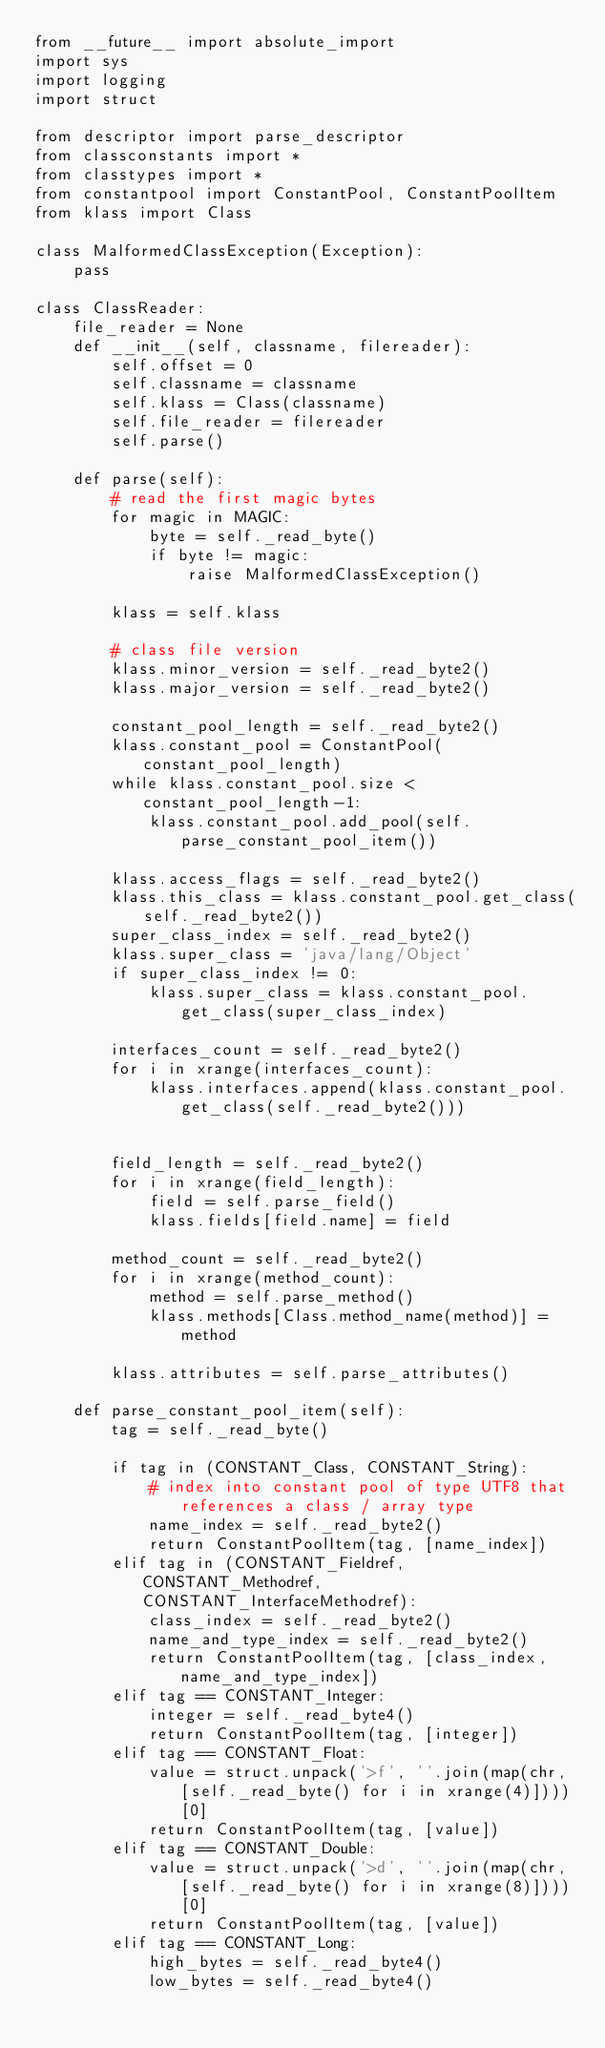Convert code to text. <code><loc_0><loc_0><loc_500><loc_500><_Python_>from __future__ import absolute_import
import sys
import logging
import struct

from descriptor import parse_descriptor
from classconstants import *
from classtypes import *
from constantpool import ConstantPool, ConstantPoolItem
from klass import Class

class MalformedClassException(Exception):
    pass

class ClassReader:
    file_reader = None
    def __init__(self, classname, filereader):
        self.offset = 0
        self.classname = classname
        self.klass = Class(classname)
        self.file_reader = filereader
        self.parse()

    def parse(self):
        # read the first magic bytes
        for magic in MAGIC:
            byte = self._read_byte()
            if byte != magic:
                raise MalformedClassException()

        klass = self.klass

        # class file version
        klass.minor_version = self._read_byte2()
        klass.major_version = self._read_byte2()

        constant_pool_length = self._read_byte2()
        klass.constant_pool = ConstantPool(constant_pool_length)
        while klass.constant_pool.size < constant_pool_length-1:
            klass.constant_pool.add_pool(self.parse_constant_pool_item())

        klass.access_flags = self._read_byte2()
        klass.this_class = klass.constant_pool.get_class(self._read_byte2())
        super_class_index = self._read_byte2()
        klass.super_class = 'java/lang/Object'
        if super_class_index != 0:
            klass.super_class = klass.constant_pool.get_class(super_class_index)

        interfaces_count = self._read_byte2()
        for i in xrange(interfaces_count):
            klass.interfaces.append(klass.constant_pool.get_class(self._read_byte2()))


        field_length = self._read_byte2()
        for i in xrange(field_length):
            field = self.parse_field()
            klass.fields[field.name] = field

        method_count = self._read_byte2()
        for i in xrange(method_count):
            method = self.parse_method()
            klass.methods[Class.method_name(method)] = method

        klass.attributes = self.parse_attributes()

    def parse_constant_pool_item(self):
        tag = self._read_byte()

        if tag in (CONSTANT_Class, CONSTANT_String):
            # index into constant pool of type UTF8 that references a class / array type
            name_index = self._read_byte2()
            return ConstantPoolItem(tag, [name_index])
        elif tag in (CONSTANT_Fieldref, CONSTANT_Methodref, CONSTANT_InterfaceMethodref):
            class_index = self._read_byte2()
            name_and_type_index = self._read_byte2()
            return ConstantPoolItem(tag, [class_index, name_and_type_index])
        elif tag == CONSTANT_Integer:
            integer = self._read_byte4()
            return ConstantPoolItem(tag, [integer])
        elif tag == CONSTANT_Float:
            value = struct.unpack('>f', ''.join(map(chr, [self._read_byte() for i in xrange(4)])))[0]
            return ConstantPoolItem(tag, [value])
        elif tag == CONSTANT_Double:
            value = struct.unpack('>d', ''.join(map(chr, [self._read_byte() for i in xrange(8)])))[0]
            return ConstantPoolItem(tag, [value])
        elif tag == CONSTANT_Long:
            high_bytes = self._read_byte4()
            low_bytes = self._read_byte4()</code> 